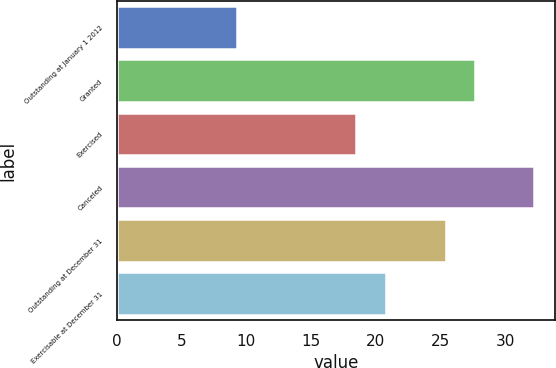Convert chart to OTSL. <chart><loc_0><loc_0><loc_500><loc_500><bar_chart><fcel>Outstanding at January 1 2012<fcel>Granted<fcel>Exercised<fcel>Canceled<fcel>Outstanding at December 31<fcel>Exercisable at December 31<nl><fcel>9.3<fcel>27.7<fcel>18.5<fcel>32.26<fcel>25.4<fcel>20.8<nl></chart> 